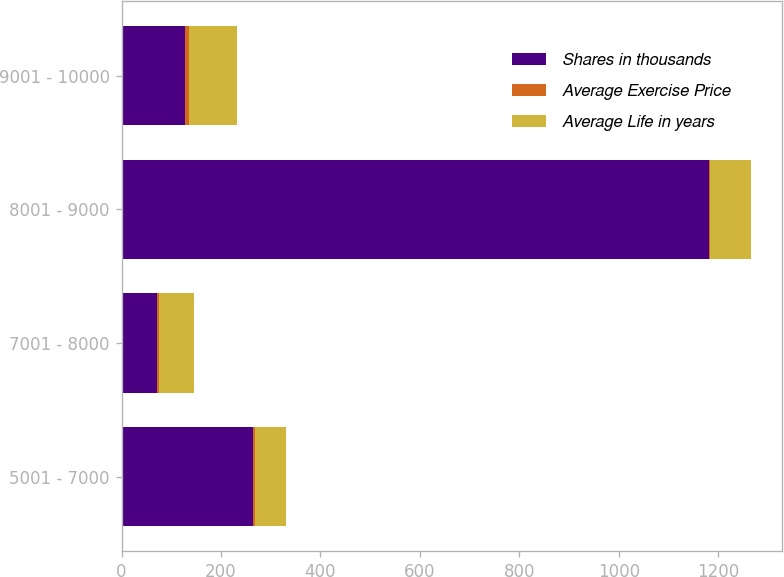Convert chart. <chart><loc_0><loc_0><loc_500><loc_500><stacked_bar_chart><ecel><fcel>5001 - 7000<fcel>7001 - 8000<fcel>8001 - 9000<fcel>9001 - 10000<nl><fcel>Shares in thousands<fcel>264<fcel>72.05<fcel>1182<fcel>127<nl><fcel>Average Exercise Price<fcel>4.85<fcel>2.52<fcel>2.3<fcel>9.18<nl><fcel>Average Life in years<fcel>61.52<fcel>72.05<fcel>81.17<fcel>96.98<nl></chart> 